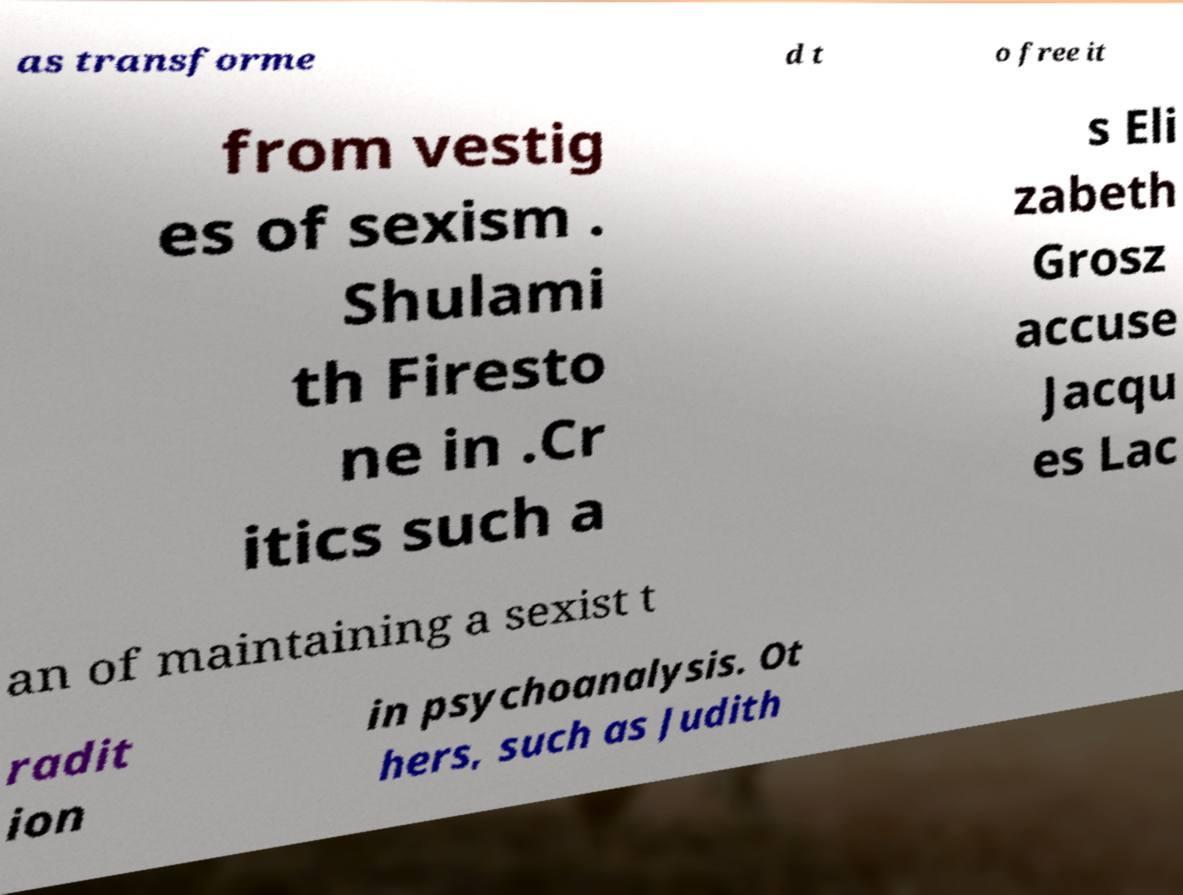Please read and relay the text visible in this image. What does it say? as transforme d t o free it from vestig es of sexism . Shulami th Firesto ne in .Cr itics such a s Eli zabeth Grosz accuse Jacqu es Lac an of maintaining a sexist t radit ion in psychoanalysis. Ot hers, such as Judith 